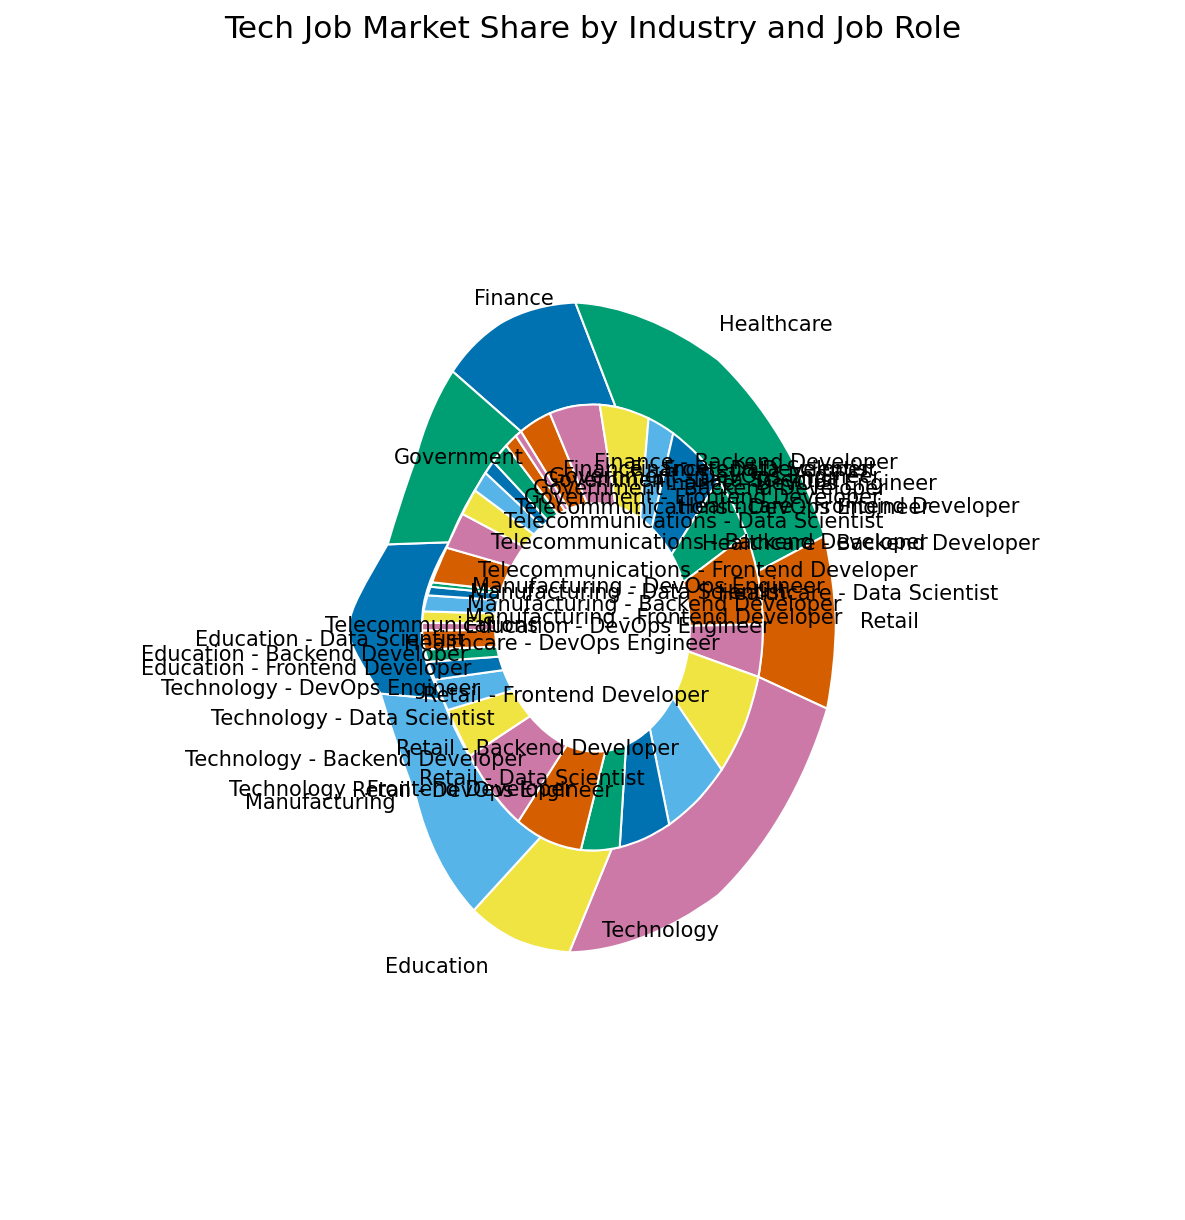Which industry has the largest market share for tech jobs? The outer circle of the nested pie chart shows the market shares of various industries. The largest outer slice corresponds to the Technology industry.
Answer: Technology Which industry has the smallest market share for tech jobs? The smallest outer slice on the pie chart corresponds to the Government industry.
Answer: Government What is the market share of Frontend Developers in the Retail industry? Find the slice labeled "Retail - Frontend Developer" within the inner circle. The market share for this role in Retail is 8%.
Answer: 8% How does the number of Backend Developers in the Technology industry compare to those in the Retail industry? Look at the inner circle slices labeled "Technology - Backend Developer" and "Retail - Backend Developer." The Technology industry has a larger segment, 12%, compared to Retail's 7%.
Answer: Technology has more Backend Developers than Retail (12% vs. 7%) How many more Data Scientists are there in Healthcare compared to Retail? Locate the segments for "Healthcare - Data Scientist" (7%) and "Retail - Data Scientist" (6%). Subtract the market shares: 7% - 6% = 1%.
Answer: 1% Which job role has the highest market share within the Technology industry? Look at the inner circle segments within the outer Technology slice. The segment "Technology - Backend Developer" with 12% is the highest.
Answer: Backend Developer Which industry has the largest market share of DevOps Engineers? Identify the inner slices labeled with "DevOps Engineer." The largest one is within the Technology industry at 6%.
Answer: Technology Are there more Frontend Developers in Finance or Backend Developers in Government? Find the inner circle slices "Finance - Frontend Developer" (5%) and "Government - Backend Developer" (3%). Finance has more Frontend Developers.
Answer: Finance has more (5% vs. 3%) What is the total market share for tech jobs in the Education and Manufacturing industries combined? Find the outer slices for Education (14%) and Manufacturing (10%), and add them together: 14% + 10% = 24%.
Answer: 24% Which job role has the smallest market share in any single industry? Look for the smallest inner slice in the chart. "Manufacturing - DevOps Engineer" and "Government - DevOps Engineer" both have the smallest segment at 1% each.
Answer: Manufacturing - DevOps Engineer and Government - DevOps Engineer (1%) 